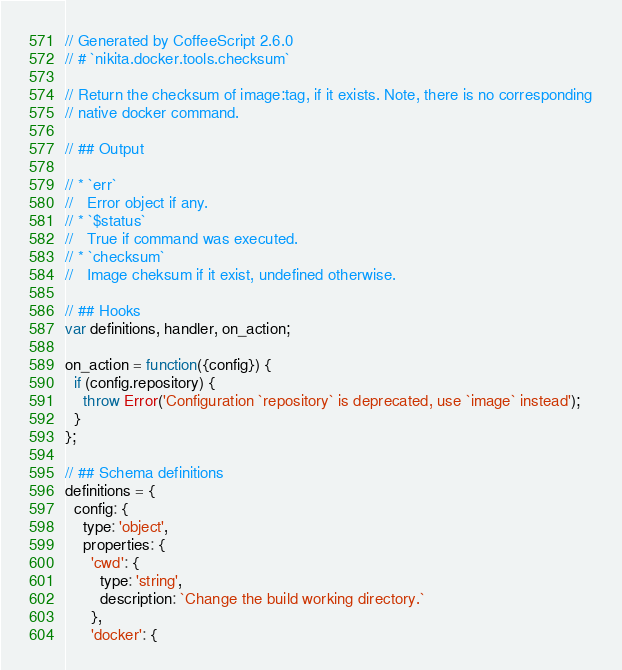Convert code to text. <code><loc_0><loc_0><loc_500><loc_500><_JavaScript_>// Generated by CoffeeScript 2.6.0
// # `nikita.docker.tools.checksum`

// Return the checksum of image:tag, if it exists. Note, there is no corresponding
// native docker command.

// ## Output

// * `err`   
//   Error object if any.
// * `$status`   
//   True if command was executed.
// * `checksum`   
//   Image cheksum if it exist, undefined otherwise.

// ## Hooks
var definitions, handler, on_action;

on_action = function({config}) {
  if (config.repository) {
    throw Error('Configuration `repository` is deprecated, use `image` instead');
  }
};

// ## Schema definitions
definitions = {
  config: {
    type: 'object',
    properties: {
      'cwd': {
        type: 'string',
        description: `Change the build working directory.`
      },
      'docker': {</code> 